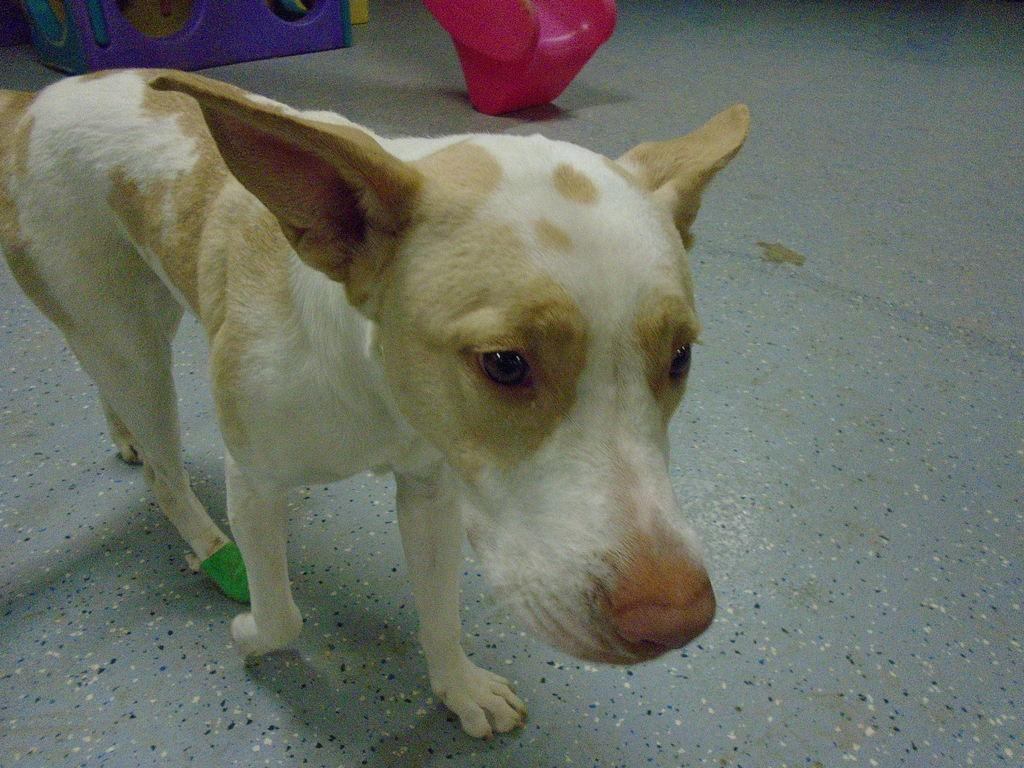What is the person in the image holding? The person in the image is holding a surfboard. Where is the person located in the image? The person is on a beach. What can be seen in the background of the image? There is a beach in the background. What type of war is being fought on the beach in the image? There is no war depicted in the image; it shows a person holding a surfboard on a beach. 